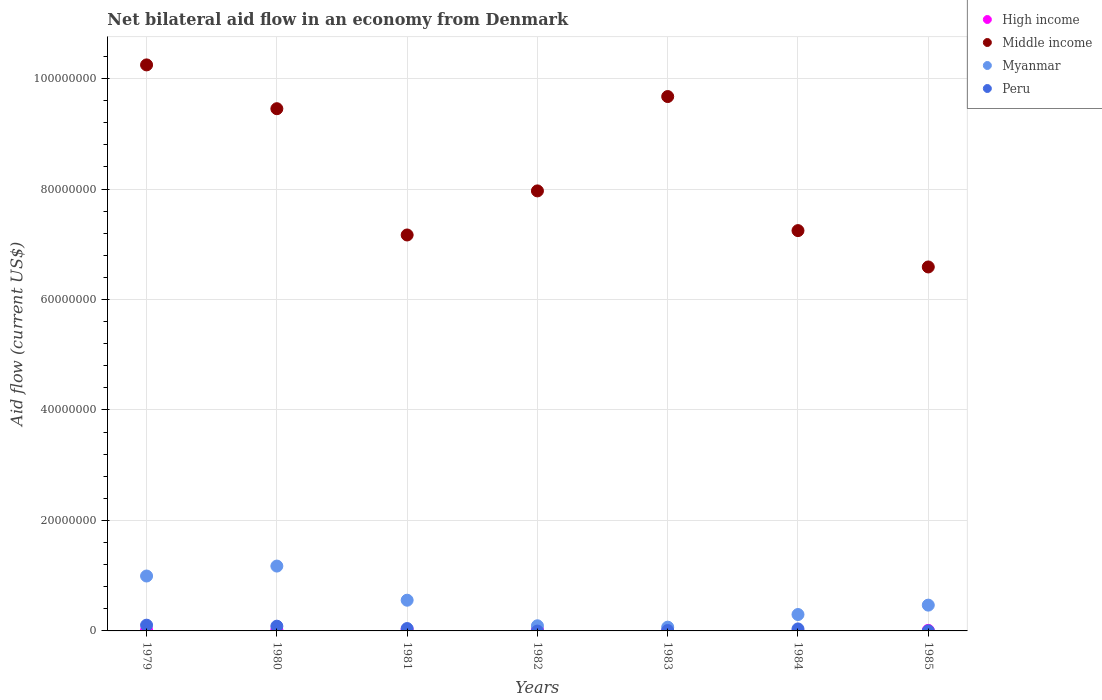How many different coloured dotlines are there?
Ensure brevity in your answer.  4. Is the number of dotlines equal to the number of legend labels?
Your response must be concise. No. What is the net bilateral aid flow in Myanmar in 1983?
Ensure brevity in your answer.  6.80e+05. Across all years, what is the maximum net bilateral aid flow in Peru?
Offer a terse response. 1.04e+06. In which year was the net bilateral aid flow in Peru maximum?
Your response must be concise. 1979. What is the total net bilateral aid flow in High income in the graph?
Your answer should be very brief. 9.50e+05. What is the difference between the net bilateral aid flow in Peru in 1979 and that in 1984?
Offer a very short reply. 6.80e+05. What is the difference between the net bilateral aid flow in Peru in 1984 and the net bilateral aid flow in Myanmar in 1981?
Offer a very short reply. -5.20e+06. What is the average net bilateral aid flow in High income per year?
Provide a short and direct response. 1.36e+05. In the year 1980, what is the difference between the net bilateral aid flow in Myanmar and net bilateral aid flow in High income?
Your answer should be very brief. 1.16e+07. In how many years, is the net bilateral aid flow in Peru greater than 88000000 US$?
Provide a short and direct response. 0. What is the ratio of the net bilateral aid flow in Middle income in 1979 to that in 1984?
Provide a succinct answer. 1.41. Is the net bilateral aid flow in High income in 1980 less than that in 1982?
Ensure brevity in your answer.  Yes. What is the difference between the highest and the second highest net bilateral aid flow in Middle income?
Offer a very short reply. 5.73e+06. What is the difference between the highest and the lowest net bilateral aid flow in High income?
Your answer should be very brief. 2.40e+05. Is the sum of the net bilateral aid flow in High income in 1982 and 1983 greater than the maximum net bilateral aid flow in Middle income across all years?
Provide a short and direct response. No. Is it the case that in every year, the sum of the net bilateral aid flow in Middle income and net bilateral aid flow in Myanmar  is greater than the sum of net bilateral aid flow in High income and net bilateral aid flow in Peru?
Ensure brevity in your answer.  Yes. Does the net bilateral aid flow in High income monotonically increase over the years?
Keep it short and to the point. No. Is the net bilateral aid flow in Peru strictly greater than the net bilateral aid flow in Myanmar over the years?
Provide a short and direct response. No. How many dotlines are there?
Provide a short and direct response. 4. How many years are there in the graph?
Provide a short and direct response. 7. What is the difference between two consecutive major ticks on the Y-axis?
Ensure brevity in your answer.  2.00e+07. Does the graph contain any zero values?
Your response must be concise. Yes. How are the legend labels stacked?
Make the answer very short. Vertical. What is the title of the graph?
Offer a terse response. Net bilateral aid flow in an economy from Denmark. Does "Malta" appear as one of the legend labels in the graph?
Ensure brevity in your answer.  No. What is the label or title of the X-axis?
Provide a succinct answer. Years. What is the label or title of the Y-axis?
Keep it short and to the point. Aid flow (current US$). What is the Aid flow (current US$) of Middle income in 1979?
Your answer should be compact. 1.02e+08. What is the Aid flow (current US$) of Myanmar in 1979?
Your answer should be compact. 9.94e+06. What is the Aid flow (current US$) in Peru in 1979?
Ensure brevity in your answer.  1.04e+06. What is the Aid flow (current US$) of Middle income in 1980?
Your response must be concise. 9.45e+07. What is the Aid flow (current US$) in Myanmar in 1980?
Offer a very short reply. 1.17e+07. What is the Aid flow (current US$) of Peru in 1980?
Your answer should be very brief. 8.60e+05. What is the Aid flow (current US$) of High income in 1981?
Provide a succinct answer. 2.40e+05. What is the Aid flow (current US$) of Middle income in 1981?
Ensure brevity in your answer.  7.17e+07. What is the Aid flow (current US$) of Myanmar in 1981?
Ensure brevity in your answer.  5.56e+06. What is the Aid flow (current US$) in Middle income in 1982?
Offer a terse response. 7.97e+07. What is the Aid flow (current US$) in Myanmar in 1982?
Your answer should be compact. 9.30e+05. What is the Aid flow (current US$) of Peru in 1982?
Provide a succinct answer. 0. What is the Aid flow (current US$) in Middle income in 1983?
Offer a terse response. 9.67e+07. What is the Aid flow (current US$) in Myanmar in 1983?
Offer a terse response. 6.80e+05. What is the Aid flow (current US$) in Middle income in 1984?
Keep it short and to the point. 7.25e+07. What is the Aid flow (current US$) in Myanmar in 1984?
Your response must be concise. 2.97e+06. What is the Aid flow (current US$) of Peru in 1984?
Give a very brief answer. 3.60e+05. What is the Aid flow (current US$) of Middle income in 1985?
Give a very brief answer. 6.59e+07. What is the Aid flow (current US$) in Myanmar in 1985?
Offer a very short reply. 4.67e+06. What is the Aid flow (current US$) in Peru in 1985?
Offer a terse response. 10000. Across all years, what is the maximum Aid flow (current US$) of Middle income?
Provide a short and direct response. 1.02e+08. Across all years, what is the maximum Aid flow (current US$) in Myanmar?
Ensure brevity in your answer.  1.17e+07. Across all years, what is the maximum Aid flow (current US$) in Peru?
Your answer should be compact. 1.04e+06. Across all years, what is the minimum Aid flow (current US$) in High income?
Offer a very short reply. 0. Across all years, what is the minimum Aid flow (current US$) of Middle income?
Keep it short and to the point. 6.59e+07. Across all years, what is the minimum Aid flow (current US$) of Myanmar?
Offer a terse response. 6.80e+05. Across all years, what is the minimum Aid flow (current US$) in Peru?
Make the answer very short. 0. What is the total Aid flow (current US$) of High income in the graph?
Keep it short and to the point. 9.50e+05. What is the total Aid flow (current US$) in Middle income in the graph?
Give a very brief answer. 5.83e+08. What is the total Aid flow (current US$) in Myanmar in the graph?
Your answer should be very brief. 3.65e+07. What is the total Aid flow (current US$) in Peru in the graph?
Give a very brief answer. 2.77e+06. What is the difference between the Aid flow (current US$) in High income in 1979 and that in 1980?
Keep it short and to the point. -4.00e+04. What is the difference between the Aid flow (current US$) in Middle income in 1979 and that in 1980?
Make the answer very short. 7.93e+06. What is the difference between the Aid flow (current US$) in Myanmar in 1979 and that in 1980?
Provide a succinct answer. -1.80e+06. What is the difference between the Aid flow (current US$) in High income in 1979 and that in 1981?
Your answer should be compact. -1.00e+05. What is the difference between the Aid flow (current US$) of Middle income in 1979 and that in 1981?
Your answer should be very brief. 3.08e+07. What is the difference between the Aid flow (current US$) of Myanmar in 1979 and that in 1981?
Your response must be concise. 4.38e+06. What is the difference between the Aid flow (current US$) of High income in 1979 and that in 1982?
Your answer should be compact. -1.00e+05. What is the difference between the Aid flow (current US$) in Middle income in 1979 and that in 1982?
Keep it short and to the point. 2.28e+07. What is the difference between the Aid flow (current US$) of Myanmar in 1979 and that in 1982?
Your answer should be very brief. 9.01e+06. What is the difference between the Aid flow (current US$) of Middle income in 1979 and that in 1983?
Your answer should be compact. 5.73e+06. What is the difference between the Aid flow (current US$) in Myanmar in 1979 and that in 1983?
Offer a very short reply. 9.26e+06. What is the difference between the Aid flow (current US$) of Peru in 1979 and that in 1983?
Keep it short and to the point. 9.70e+05. What is the difference between the Aid flow (current US$) of Middle income in 1979 and that in 1984?
Give a very brief answer. 3.00e+07. What is the difference between the Aid flow (current US$) of Myanmar in 1979 and that in 1984?
Make the answer very short. 6.97e+06. What is the difference between the Aid flow (current US$) of Peru in 1979 and that in 1984?
Make the answer very short. 6.80e+05. What is the difference between the Aid flow (current US$) of Middle income in 1979 and that in 1985?
Provide a short and direct response. 3.66e+07. What is the difference between the Aid flow (current US$) of Myanmar in 1979 and that in 1985?
Your response must be concise. 5.27e+06. What is the difference between the Aid flow (current US$) in Peru in 1979 and that in 1985?
Ensure brevity in your answer.  1.03e+06. What is the difference between the Aid flow (current US$) of High income in 1980 and that in 1981?
Provide a short and direct response. -6.00e+04. What is the difference between the Aid flow (current US$) of Middle income in 1980 and that in 1981?
Offer a terse response. 2.29e+07. What is the difference between the Aid flow (current US$) in Myanmar in 1980 and that in 1981?
Give a very brief answer. 6.18e+06. What is the difference between the Aid flow (current US$) in Peru in 1980 and that in 1981?
Your answer should be compact. 4.30e+05. What is the difference between the Aid flow (current US$) in High income in 1980 and that in 1982?
Ensure brevity in your answer.  -6.00e+04. What is the difference between the Aid flow (current US$) in Middle income in 1980 and that in 1982?
Your answer should be very brief. 1.49e+07. What is the difference between the Aid flow (current US$) in Myanmar in 1980 and that in 1982?
Offer a terse response. 1.08e+07. What is the difference between the Aid flow (current US$) of Middle income in 1980 and that in 1983?
Provide a short and direct response. -2.20e+06. What is the difference between the Aid flow (current US$) of Myanmar in 1980 and that in 1983?
Your answer should be compact. 1.11e+07. What is the difference between the Aid flow (current US$) of Peru in 1980 and that in 1983?
Provide a succinct answer. 7.90e+05. What is the difference between the Aid flow (current US$) of Middle income in 1980 and that in 1984?
Give a very brief answer. 2.21e+07. What is the difference between the Aid flow (current US$) of Myanmar in 1980 and that in 1984?
Offer a terse response. 8.77e+06. What is the difference between the Aid flow (current US$) of Middle income in 1980 and that in 1985?
Make the answer very short. 2.86e+07. What is the difference between the Aid flow (current US$) in Myanmar in 1980 and that in 1985?
Offer a terse response. 7.07e+06. What is the difference between the Aid flow (current US$) in Peru in 1980 and that in 1985?
Your answer should be compact. 8.50e+05. What is the difference between the Aid flow (current US$) of High income in 1981 and that in 1982?
Make the answer very short. 0. What is the difference between the Aid flow (current US$) in Middle income in 1981 and that in 1982?
Offer a very short reply. -7.98e+06. What is the difference between the Aid flow (current US$) in Myanmar in 1981 and that in 1982?
Your response must be concise. 4.63e+06. What is the difference between the Aid flow (current US$) of Middle income in 1981 and that in 1983?
Your answer should be very brief. -2.51e+07. What is the difference between the Aid flow (current US$) of Myanmar in 1981 and that in 1983?
Your response must be concise. 4.88e+06. What is the difference between the Aid flow (current US$) of Middle income in 1981 and that in 1984?
Ensure brevity in your answer.  -7.90e+05. What is the difference between the Aid flow (current US$) in Myanmar in 1981 and that in 1984?
Offer a terse response. 2.59e+06. What is the difference between the Aid flow (current US$) of Peru in 1981 and that in 1984?
Provide a short and direct response. 7.00e+04. What is the difference between the Aid flow (current US$) in Middle income in 1981 and that in 1985?
Give a very brief answer. 5.79e+06. What is the difference between the Aid flow (current US$) in Myanmar in 1981 and that in 1985?
Provide a short and direct response. 8.90e+05. What is the difference between the Aid flow (current US$) in Peru in 1981 and that in 1985?
Make the answer very short. 4.20e+05. What is the difference between the Aid flow (current US$) of High income in 1982 and that in 1983?
Provide a short and direct response. 1.90e+05. What is the difference between the Aid flow (current US$) in Middle income in 1982 and that in 1983?
Provide a short and direct response. -1.71e+07. What is the difference between the Aid flow (current US$) of Middle income in 1982 and that in 1984?
Ensure brevity in your answer.  7.19e+06. What is the difference between the Aid flow (current US$) in Myanmar in 1982 and that in 1984?
Your response must be concise. -2.04e+06. What is the difference between the Aid flow (current US$) of High income in 1982 and that in 1985?
Your answer should be very brief. 1.40e+05. What is the difference between the Aid flow (current US$) in Middle income in 1982 and that in 1985?
Make the answer very short. 1.38e+07. What is the difference between the Aid flow (current US$) in Myanmar in 1982 and that in 1985?
Your answer should be very brief. -3.74e+06. What is the difference between the Aid flow (current US$) of Middle income in 1983 and that in 1984?
Ensure brevity in your answer.  2.43e+07. What is the difference between the Aid flow (current US$) in Myanmar in 1983 and that in 1984?
Ensure brevity in your answer.  -2.29e+06. What is the difference between the Aid flow (current US$) in Peru in 1983 and that in 1984?
Give a very brief answer. -2.90e+05. What is the difference between the Aid flow (current US$) of High income in 1983 and that in 1985?
Provide a succinct answer. -5.00e+04. What is the difference between the Aid flow (current US$) of Middle income in 1983 and that in 1985?
Make the answer very short. 3.08e+07. What is the difference between the Aid flow (current US$) of Myanmar in 1983 and that in 1985?
Ensure brevity in your answer.  -3.99e+06. What is the difference between the Aid flow (current US$) of Middle income in 1984 and that in 1985?
Give a very brief answer. 6.58e+06. What is the difference between the Aid flow (current US$) of Myanmar in 1984 and that in 1985?
Keep it short and to the point. -1.70e+06. What is the difference between the Aid flow (current US$) in Peru in 1984 and that in 1985?
Your answer should be compact. 3.50e+05. What is the difference between the Aid flow (current US$) of High income in 1979 and the Aid flow (current US$) of Middle income in 1980?
Ensure brevity in your answer.  -9.44e+07. What is the difference between the Aid flow (current US$) of High income in 1979 and the Aid flow (current US$) of Myanmar in 1980?
Offer a very short reply. -1.16e+07. What is the difference between the Aid flow (current US$) of High income in 1979 and the Aid flow (current US$) of Peru in 1980?
Make the answer very short. -7.20e+05. What is the difference between the Aid flow (current US$) in Middle income in 1979 and the Aid flow (current US$) in Myanmar in 1980?
Give a very brief answer. 9.07e+07. What is the difference between the Aid flow (current US$) in Middle income in 1979 and the Aid flow (current US$) in Peru in 1980?
Make the answer very short. 1.02e+08. What is the difference between the Aid flow (current US$) of Myanmar in 1979 and the Aid flow (current US$) of Peru in 1980?
Your response must be concise. 9.08e+06. What is the difference between the Aid flow (current US$) in High income in 1979 and the Aid flow (current US$) in Middle income in 1981?
Your answer should be compact. -7.15e+07. What is the difference between the Aid flow (current US$) in High income in 1979 and the Aid flow (current US$) in Myanmar in 1981?
Keep it short and to the point. -5.42e+06. What is the difference between the Aid flow (current US$) of High income in 1979 and the Aid flow (current US$) of Peru in 1981?
Your answer should be compact. -2.90e+05. What is the difference between the Aid flow (current US$) in Middle income in 1979 and the Aid flow (current US$) in Myanmar in 1981?
Your response must be concise. 9.69e+07. What is the difference between the Aid flow (current US$) of Middle income in 1979 and the Aid flow (current US$) of Peru in 1981?
Your answer should be compact. 1.02e+08. What is the difference between the Aid flow (current US$) of Myanmar in 1979 and the Aid flow (current US$) of Peru in 1981?
Provide a succinct answer. 9.51e+06. What is the difference between the Aid flow (current US$) of High income in 1979 and the Aid flow (current US$) of Middle income in 1982?
Keep it short and to the point. -7.95e+07. What is the difference between the Aid flow (current US$) of High income in 1979 and the Aid flow (current US$) of Myanmar in 1982?
Your answer should be very brief. -7.90e+05. What is the difference between the Aid flow (current US$) in Middle income in 1979 and the Aid flow (current US$) in Myanmar in 1982?
Give a very brief answer. 1.02e+08. What is the difference between the Aid flow (current US$) of High income in 1979 and the Aid flow (current US$) of Middle income in 1983?
Provide a short and direct response. -9.66e+07. What is the difference between the Aid flow (current US$) in High income in 1979 and the Aid flow (current US$) in Myanmar in 1983?
Provide a short and direct response. -5.40e+05. What is the difference between the Aid flow (current US$) in High income in 1979 and the Aid flow (current US$) in Peru in 1983?
Provide a succinct answer. 7.00e+04. What is the difference between the Aid flow (current US$) in Middle income in 1979 and the Aid flow (current US$) in Myanmar in 1983?
Keep it short and to the point. 1.02e+08. What is the difference between the Aid flow (current US$) of Middle income in 1979 and the Aid flow (current US$) of Peru in 1983?
Your answer should be very brief. 1.02e+08. What is the difference between the Aid flow (current US$) in Myanmar in 1979 and the Aid flow (current US$) in Peru in 1983?
Offer a very short reply. 9.87e+06. What is the difference between the Aid flow (current US$) of High income in 1979 and the Aid flow (current US$) of Middle income in 1984?
Your response must be concise. -7.23e+07. What is the difference between the Aid flow (current US$) of High income in 1979 and the Aid flow (current US$) of Myanmar in 1984?
Your answer should be very brief. -2.83e+06. What is the difference between the Aid flow (current US$) of Middle income in 1979 and the Aid flow (current US$) of Myanmar in 1984?
Your response must be concise. 9.95e+07. What is the difference between the Aid flow (current US$) of Middle income in 1979 and the Aid flow (current US$) of Peru in 1984?
Your answer should be compact. 1.02e+08. What is the difference between the Aid flow (current US$) of Myanmar in 1979 and the Aid flow (current US$) of Peru in 1984?
Offer a very short reply. 9.58e+06. What is the difference between the Aid flow (current US$) of High income in 1979 and the Aid flow (current US$) of Middle income in 1985?
Keep it short and to the point. -6.58e+07. What is the difference between the Aid flow (current US$) of High income in 1979 and the Aid flow (current US$) of Myanmar in 1985?
Give a very brief answer. -4.53e+06. What is the difference between the Aid flow (current US$) in Middle income in 1979 and the Aid flow (current US$) in Myanmar in 1985?
Make the answer very short. 9.78e+07. What is the difference between the Aid flow (current US$) in Middle income in 1979 and the Aid flow (current US$) in Peru in 1985?
Offer a terse response. 1.02e+08. What is the difference between the Aid flow (current US$) in Myanmar in 1979 and the Aid flow (current US$) in Peru in 1985?
Your answer should be very brief. 9.93e+06. What is the difference between the Aid flow (current US$) in High income in 1980 and the Aid flow (current US$) in Middle income in 1981?
Make the answer very short. -7.15e+07. What is the difference between the Aid flow (current US$) of High income in 1980 and the Aid flow (current US$) of Myanmar in 1981?
Your response must be concise. -5.38e+06. What is the difference between the Aid flow (current US$) in High income in 1980 and the Aid flow (current US$) in Peru in 1981?
Provide a short and direct response. -2.50e+05. What is the difference between the Aid flow (current US$) in Middle income in 1980 and the Aid flow (current US$) in Myanmar in 1981?
Provide a succinct answer. 8.90e+07. What is the difference between the Aid flow (current US$) of Middle income in 1980 and the Aid flow (current US$) of Peru in 1981?
Your answer should be very brief. 9.41e+07. What is the difference between the Aid flow (current US$) of Myanmar in 1980 and the Aid flow (current US$) of Peru in 1981?
Offer a very short reply. 1.13e+07. What is the difference between the Aid flow (current US$) of High income in 1980 and the Aid flow (current US$) of Middle income in 1982?
Give a very brief answer. -7.95e+07. What is the difference between the Aid flow (current US$) of High income in 1980 and the Aid flow (current US$) of Myanmar in 1982?
Keep it short and to the point. -7.50e+05. What is the difference between the Aid flow (current US$) of Middle income in 1980 and the Aid flow (current US$) of Myanmar in 1982?
Provide a short and direct response. 9.36e+07. What is the difference between the Aid flow (current US$) in High income in 1980 and the Aid flow (current US$) in Middle income in 1983?
Your answer should be very brief. -9.66e+07. What is the difference between the Aid flow (current US$) in High income in 1980 and the Aid flow (current US$) in Myanmar in 1983?
Your response must be concise. -5.00e+05. What is the difference between the Aid flow (current US$) in Middle income in 1980 and the Aid flow (current US$) in Myanmar in 1983?
Keep it short and to the point. 9.39e+07. What is the difference between the Aid flow (current US$) in Middle income in 1980 and the Aid flow (current US$) in Peru in 1983?
Provide a succinct answer. 9.45e+07. What is the difference between the Aid flow (current US$) of Myanmar in 1980 and the Aid flow (current US$) of Peru in 1983?
Provide a succinct answer. 1.17e+07. What is the difference between the Aid flow (current US$) of High income in 1980 and the Aid flow (current US$) of Middle income in 1984?
Give a very brief answer. -7.23e+07. What is the difference between the Aid flow (current US$) of High income in 1980 and the Aid flow (current US$) of Myanmar in 1984?
Provide a succinct answer. -2.79e+06. What is the difference between the Aid flow (current US$) in Middle income in 1980 and the Aid flow (current US$) in Myanmar in 1984?
Your answer should be very brief. 9.16e+07. What is the difference between the Aid flow (current US$) in Middle income in 1980 and the Aid flow (current US$) in Peru in 1984?
Ensure brevity in your answer.  9.42e+07. What is the difference between the Aid flow (current US$) of Myanmar in 1980 and the Aid flow (current US$) of Peru in 1984?
Your answer should be compact. 1.14e+07. What is the difference between the Aid flow (current US$) in High income in 1980 and the Aid flow (current US$) in Middle income in 1985?
Your response must be concise. -6.57e+07. What is the difference between the Aid flow (current US$) in High income in 1980 and the Aid flow (current US$) in Myanmar in 1985?
Your response must be concise. -4.49e+06. What is the difference between the Aid flow (current US$) in High income in 1980 and the Aid flow (current US$) in Peru in 1985?
Give a very brief answer. 1.70e+05. What is the difference between the Aid flow (current US$) in Middle income in 1980 and the Aid flow (current US$) in Myanmar in 1985?
Your answer should be very brief. 8.99e+07. What is the difference between the Aid flow (current US$) of Middle income in 1980 and the Aid flow (current US$) of Peru in 1985?
Offer a very short reply. 9.45e+07. What is the difference between the Aid flow (current US$) of Myanmar in 1980 and the Aid flow (current US$) of Peru in 1985?
Keep it short and to the point. 1.17e+07. What is the difference between the Aid flow (current US$) in High income in 1981 and the Aid flow (current US$) in Middle income in 1982?
Offer a very short reply. -7.94e+07. What is the difference between the Aid flow (current US$) of High income in 1981 and the Aid flow (current US$) of Myanmar in 1982?
Your answer should be compact. -6.90e+05. What is the difference between the Aid flow (current US$) of Middle income in 1981 and the Aid flow (current US$) of Myanmar in 1982?
Your answer should be very brief. 7.08e+07. What is the difference between the Aid flow (current US$) in High income in 1981 and the Aid flow (current US$) in Middle income in 1983?
Your answer should be compact. -9.65e+07. What is the difference between the Aid flow (current US$) in High income in 1981 and the Aid flow (current US$) in Myanmar in 1983?
Your answer should be compact. -4.40e+05. What is the difference between the Aid flow (current US$) of High income in 1981 and the Aid flow (current US$) of Peru in 1983?
Ensure brevity in your answer.  1.70e+05. What is the difference between the Aid flow (current US$) of Middle income in 1981 and the Aid flow (current US$) of Myanmar in 1983?
Offer a very short reply. 7.10e+07. What is the difference between the Aid flow (current US$) in Middle income in 1981 and the Aid flow (current US$) in Peru in 1983?
Your answer should be compact. 7.16e+07. What is the difference between the Aid flow (current US$) of Myanmar in 1981 and the Aid flow (current US$) of Peru in 1983?
Your response must be concise. 5.49e+06. What is the difference between the Aid flow (current US$) of High income in 1981 and the Aid flow (current US$) of Middle income in 1984?
Keep it short and to the point. -7.22e+07. What is the difference between the Aid flow (current US$) in High income in 1981 and the Aid flow (current US$) in Myanmar in 1984?
Keep it short and to the point. -2.73e+06. What is the difference between the Aid flow (current US$) in Middle income in 1981 and the Aid flow (current US$) in Myanmar in 1984?
Your answer should be very brief. 6.87e+07. What is the difference between the Aid flow (current US$) in Middle income in 1981 and the Aid flow (current US$) in Peru in 1984?
Provide a short and direct response. 7.13e+07. What is the difference between the Aid flow (current US$) in Myanmar in 1981 and the Aid flow (current US$) in Peru in 1984?
Keep it short and to the point. 5.20e+06. What is the difference between the Aid flow (current US$) of High income in 1981 and the Aid flow (current US$) of Middle income in 1985?
Keep it short and to the point. -6.56e+07. What is the difference between the Aid flow (current US$) in High income in 1981 and the Aid flow (current US$) in Myanmar in 1985?
Make the answer very short. -4.43e+06. What is the difference between the Aid flow (current US$) in Middle income in 1981 and the Aid flow (current US$) in Myanmar in 1985?
Keep it short and to the point. 6.70e+07. What is the difference between the Aid flow (current US$) of Middle income in 1981 and the Aid flow (current US$) of Peru in 1985?
Your answer should be very brief. 7.17e+07. What is the difference between the Aid flow (current US$) of Myanmar in 1981 and the Aid flow (current US$) of Peru in 1985?
Offer a very short reply. 5.55e+06. What is the difference between the Aid flow (current US$) in High income in 1982 and the Aid flow (current US$) in Middle income in 1983?
Offer a terse response. -9.65e+07. What is the difference between the Aid flow (current US$) in High income in 1982 and the Aid flow (current US$) in Myanmar in 1983?
Your response must be concise. -4.40e+05. What is the difference between the Aid flow (current US$) in Middle income in 1982 and the Aid flow (current US$) in Myanmar in 1983?
Provide a succinct answer. 7.90e+07. What is the difference between the Aid flow (current US$) in Middle income in 1982 and the Aid flow (current US$) in Peru in 1983?
Keep it short and to the point. 7.96e+07. What is the difference between the Aid flow (current US$) in Myanmar in 1982 and the Aid flow (current US$) in Peru in 1983?
Provide a succinct answer. 8.60e+05. What is the difference between the Aid flow (current US$) of High income in 1982 and the Aid flow (current US$) of Middle income in 1984?
Offer a very short reply. -7.22e+07. What is the difference between the Aid flow (current US$) of High income in 1982 and the Aid flow (current US$) of Myanmar in 1984?
Offer a terse response. -2.73e+06. What is the difference between the Aid flow (current US$) in High income in 1982 and the Aid flow (current US$) in Peru in 1984?
Offer a very short reply. -1.20e+05. What is the difference between the Aid flow (current US$) of Middle income in 1982 and the Aid flow (current US$) of Myanmar in 1984?
Offer a very short reply. 7.67e+07. What is the difference between the Aid flow (current US$) in Middle income in 1982 and the Aid flow (current US$) in Peru in 1984?
Give a very brief answer. 7.93e+07. What is the difference between the Aid flow (current US$) in Myanmar in 1982 and the Aid flow (current US$) in Peru in 1984?
Make the answer very short. 5.70e+05. What is the difference between the Aid flow (current US$) in High income in 1982 and the Aid flow (current US$) in Middle income in 1985?
Ensure brevity in your answer.  -6.56e+07. What is the difference between the Aid flow (current US$) in High income in 1982 and the Aid flow (current US$) in Myanmar in 1985?
Your answer should be very brief. -4.43e+06. What is the difference between the Aid flow (current US$) in High income in 1982 and the Aid flow (current US$) in Peru in 1985?
Provide a succinct answer. 2.30e+05. What is the difference between the Aid flow (current US$) in Middle income in 1982 and the Aid flow (current US$) in Myanmar in 1985?
Your response must be concise. 7.50e+07. What is the difference between the Aid flow (current US$) in Middle income in 1982 and the Aid flow (current US$) in Peru in 1985?
Offer a terse response. 7.96e+07. What is the difference between the Aid flow (current US$) in Myanmar in 1982 and the Aid flow (current US$) in Peru in 1985?
Keep it short and to the point. 9.20e+05. What is the difference between the Aid flow (current US$) in High income in 1983 and the Aid flow (current US$) in Middle income in 1984?
Provide a succinct answer. -7.24e+07. What is the difference between the Aid flow (current US$) of High income in 1983 and the Aid flow (current US$) of Myanmar in 1984?
Your response must be concise. -2.92e+06. What is the difference between the Aid flow (current US$) of High income in 1983 and the Aid flow (current US$) of Peru in 1984?
Ensure brevity in your answer.  -3.10e+05. What is the difference between the Aid flow (current US$) in Middle income in 1983 and the Aid flow (current US$) in Myanmar in 1984?
Keep it short and to the point. 9.38e+07. What is the difference between the Aid flow (current US$) of Middle income in 1983 and the Aid flow (current US$) of Peru in 1984?
Make the answer very short. 9.64e+07. What is the difference between the Aid flow (current US$) of Myanmar in 1983 and the Aid flow (current US$) of Peru in 1984?
Keep it short and to the point. 3.20e+05. What is the difference between the Aid flow (current US$) in High income in 1983 and the Aid flow (current US$) in Middle income in 1985?
Your answer should be very brief. -6.58e+07. What is the difference between the Aid flow (current US$) of High income in 1983 and the Aid flow (current US$) of Myanmar in 1985?
Ensure brevity in your answer.  -4.62e+06. What is the difference between the Aid flow (current US$) of High income in 1983 and the Aid flow (current US$) of Peru in 1985?
Your answer should be very brief. 4.00e+04. What is the difference between the Aid flow (current US$) in Middle income in 1983 and the Aid flow (current US$) in Myanmar in 1985?
Give a very brief answer. 9.21e+07. What is the difference between the Aid flow (current US$) of Middle income in 1983 and the Aid flow (current US$) of Peru in 1985?
Make the answer very short. 9.67e+07. What is the difference between the Aid flow (current US$) of Myanmar in 1983 and the Aid flow (current US$) of Peru in 1985?
Offer a terse response. 6.70e+05. What is the difference between the Aid flow (current US$) of Middle income in 1984 and the Aid flow (current US$) of Myanmar in 1985?
Keep it short and to the point. 6.78e+07. What is the difference between the Aid flow (current US$) of Middle income in 1984 and the Aid flow (current US$) of Peru in 1985?
Provide a succinct answer. 7.25e+07. What is the difference between the Aid flow (current US$) of Myanmar in 1984 and the Aid flow (current US$) of Peru in 1985?
Your response must be concise. 2.96e+06. What is the average Aid flow (current US$) of High income per year?
Make the answer very short. 1.36e+05. What is the average Aid flow (current US$) of Middle income per year?
Offer a very short reply. 8.34e+07. What is the average Aid flow (current US$) of Myanmar per year?
Offer a very short reply. 5.21e+06. What is the average Aid flow (current US$) in Peru per year?
Offer a terse response. 3.96e+05. In the year 1979, what is the difference between the Aid flow (current US$) in High income and Aid flow (current US$) in Middle income?
Offer a very short reply. -1.02e+08. In the year 1979, what is the difference between the Aid flow (current US$) of High income and Aid flow (current US$) of Myanmar?
Offer a very short reply. -9.80e+06. In the year 1979, what is the difference between the Aid flow (current US$) of High income and Aid flow (current US$) of Peru?
Your response must be concise. -9.00e+05. In the year 1979, what is the difference between the Aid flow (current US$) of Middle income and Aid flow (current US$) of Myanmar?
Ensure brevity in your answer.  9.25e+07. In the year 1979, what is the difference between the Aid flow (current US$) in Middle income and Aid flow (current US$) in Peru?
Your response must be concise. 1.01e+08. In the year 1979, what is the difference between the Aid flow (current US$) of Myanmar and Aid flow (current US$) of Peru?
Offer a very short reply. 8.90e+06. In the year 1980, what is the difference between the Aid flow (current US$) in High income and Aid flow (current US$) in Middle income?
Ensure brevity in your answer.  -9.44e+07. In the year 1980, what is the difference between the Aid flow (current US$) of High income and Aid flow (current US$) of Myanmar?
Your response must be concise. -1.16e+07. In the year 1980, what is the difference between the Aid flow (current US$) in High income and Aid flow (current US$) in Peru?
Provide a succinct answer. -6.80e+05. In the year 1980, what is the difference between the Aid flow (current US$) in Middle income and Aid flow (current US$) in Myanmar?
Provide a short and direct response. 8.28e+07. In the year 1980, what is the difference between the Aid flow (current US$) of Middle income and Aid flow (current US$) of Peru?
Your answer should be very brief. 9.37e+07. In the year 1980, what is the difference between the Aid flow (current US$) of Myanmar and Aid flow (current US$) of Peru?
Make the answer very short. 1.09e+07. In the year 1981, what is the difference between the Aid flow (current US$) of High income and Aid flow (current US$) of Middle income?
Your answer should be very brief. -7.14e+07. In the year 1981, what is the difference between the Aid flow (current US$) in High income and Aid flow (current US$) in Myanmar?
Give a very brief answer. -5.32e+06. In the year 1981, what is the difference between the Aid flow (current US$) of High income and Aid flow (current US$) of Peru?
Keep it short and to the point. -1.90e+05. In the year 1981, what is the difference between the Aid flow (current US$) in Middle income and Aid flow (current US$) in Myanmar?
Provide a succinct answer. 6.61e+07. In the year 1981, what is the difference between the Aid flow (current US$) of Middle income and Aid flow (current US$) of Peru?
Provide a succinct answer. 7.12e+07. In the year 1981, what is the difference between the Aid flow (current US$) in Myanmar and Aid flow (current US$) in Peru?
Your answer should be very brief. 5.13e+06. In the year 1982, what is the difference between the Aid flow (current US$) of High income and Aid flow (current US$) of Middle income?
Keep it short and to the point. -7.94e+07. In the year 1982, what is the difference between the Aid flow (current US$) of High income and Aid flow (current US$) of Myanmar?
Give a very brief answer. -6.90e+05. In the year 1982, what is the difference between the Aid flow (current US$) of Middle income and Aid flow (current US$) of Myanmar?
Ensure brevity in your answer.  7.87e+07. In the year 1983, what is the difference between the Aid flow (current US$) in High income and Aid flow (current US$) in Middle income?
Provide a succinct answer. -9.67e+07. In the year 1983, what is the difference between the Aid flow (current US$) in High income and Aid flow (current US$) in Myanmar?
Give a very brief answer. -6.30e+05. In the year 1983, what is the difference between the Aid flow (current US$) of High income and Aid flow (current US$) of Peru?
Offer a terse response. -2.00e+04. In the year 1983, what is the difference between the Aid flow (current US$) in Middle income and Aid flow (current US$) in Myanmar?
Your answer should be very brief. 9.61e+07. In the year 1983, what is the difference between the Aid flow (current US$) of Middle income and Aid flow (current US$) of Peru?
Your response must be concise. 9.67e+07. In the year 1984, what is the difference between the Aid flow (current US$) in Middle income and Aid flow (current US$) in Myanmar?
Provide a succinct answer. 6.95e+07. In the year 1984, what is the difference between the Aid flow (current US$) in Middle income and Aid flow (current US$) in Peru?
Make the answer very short. 7.21e+07. In the year 1984, what is the difference between the Aid flow (current US$) in Myanmar and Aid flow (current US$) in Peru?
Ensure brevity in your answer.  2.61e+06. In the year 1985, what is the difference between the Aid flow (current US$) in High income and Aid flow (current US$) in Middle income?
Keep it short and to the point. -6.58e+07. In the year 1985, what is the difference between the Aid flow (current US$) in High income and Aid flow (current US$) in Myanmar?
Offer a very short reply. -4.57e+06. In the year 1985, what is the difference between the Aid flow (current US$) in High income and Aid flow (current US$) in Peru?
Make the answer very short. 9.00e+04. In the year 1985, what is the difference between the Aid flow (current US$) of Middle income and Aid flow (current US$) of Myanmar?
Offer a very short reply. 6.12e+07. In the year 1985, what is the difference between the Aid flow (current US$) in Middle income and Aid flow (current US$) in Peru?
Make the answer very short. 6.59e+07. In the year 1985, what is the difference between the Aid flow (current US$) in Myanmar and Aid flow (current US$) in Peru?
Give a very brief answer. 4.66e+06. What is the ratio of the Aid flow (current US$) of High income in 1979 to that in 1980?
Make the answer very short. 0.78. What is the ratio of the Aid flow (current US$) in Middle income in 1979 to that in 1980?
Ensure brevity in your answer.  1.08. What is the ratio of the Aid flow (current US$) of Myanmar in 1979 to that in 1980?
Offer a terse response. 0.85. What is the ratio of the Aid flow (current US$) of Peru in 1979 to that in 1980?
Provide a short and direct response. 1.21. What is the ratio of the Aid flow (current US$) of High income in 1979 to that in 1981?
Offer a very short reply. 0.58. What is the ratio of the Aid flow (current US$) in Middle income in 1979 to that in 1981?
Your answer should be very brief. 1.43. What is the ratio of the Aid flow (current US$) in Myanmar in 1979 to that in 1981?
Offer a terse response. 1.79. What is the ratio of the Aid flow (current US$) of Peru in 1979 to that in 1981?
Offer a very short reply. 2.42. What is the ratio of the Aid flow (current US$) of High income in 1979 to that in 1982?
Offer a very short reply. 0.58. What is the ratio of the Aid flow (current US$) of Middle income in 1979 to that in 1982?
Offer a very short reply. 1.29. What is the ratio of the Aid flow (current US$) of Myanmar in 1979 to that in 1982?
Ensure brevity in your answer.  10.69. What is the ratio of the Aid flow (current US$) in Middle income in 1979 to that in 1983?
Ensure brevity in your answer.  1.06. What is the ratio of the Aid flow (current US$) in Myanmar in 1979 to that in 1983?
Offer a terse response. 14.62. What is the ratio of the Aid flow (current US$) in Peru in 1979 to that in 1983?
Ensure brevity in your answer.  14.86. What is the ratio of the Aid flow (current US$) of Middle income in 1979 to that in 1984?
Your response must be concise. 1.41. What is the ratio of the Aid flow (current US$) of Myanmar in 1979 to that in 1984?
Your response must be concise. 3.35. What is the ratio of the Aid flow (current US$) in Peru in 1979 to that in 1984?
Provide a succinct answer. 2.89. What is the ratio of the Aid flow (current US$) of Middle income in 1979 to that in 1985?
Ensure brevity in your answer.  1.56. What is the ratio of the Aid flow (current US$) in Myanmar in 1979 to that in 1985?
Keep it short and to the point. 2.13. What is the ratio of the Aid flow (current US$) in Peru in 1979 to that in 1985?
Provide a short and direct response. 104. What is the ratio of the Aid flow (current US$) of Middle income in 1980 to that in 1981?
Provide a succinct answer. 1.32. What is the ratio of the Aid flow (current US$) of Myanmar in 1980 to that in 1981?
Give a very brief answer. 2.11. What is the ratio of the Aid flow (current US$) in Peru in 1980 to that in 1981?
Your answer should be compact. 2. What is the ratio of the Aid flow (current US$) in Middle income in 1980 to that in 1982?
Keep it short and to the point. 1.19. What is the ratio of the Aid flow (current US$) of Myanmar in 1980 to that in 1982?
Your answer should be compact. 12.62. What is the ratio of the Aid flow (current US$) in High income in 1980 to that in 1983?
Offer a terse response. 3.6. What is the ratio of the Aid flow (current US$) in Middle income in 1980 to that in 1983?
Provide a succinct answer. 0.98. What is the ratio of the Aid flow (current US$) of Myanmar in 1980 to that in 1983?
Make the answer very short. 17.26. What is the ratio of the Aid flow (current US$) of Peru in 1980 to that in 1983?
Give a very brief answer. 12.29. What is the ratio of the Aid flow (current US$) of Middle income in 1980 to that in 1984?
Keep it short and to the point. 1.3. What is the ratio of the Aid flow (current US$) of Myanmar in 1980 to that in 1984?
Your answer should be compact. 3.95. What is the ratio of the Aid flow (current US$) in Peru in 1980 to that in 1984?
Your answer should be compact. 2.39. What is the ratio of the Aid flow (current US$) of Middle income in 1980 to that in 1985?
Your answer should be very brief. 1.43. What is the ratio of the Aid flow (current US$) in Myanmar in 1980 to that in 1985?
Offer a terse response. 2.51. What is the ratio of the Aid flow (current US$) in Peru in 1980 to that in 1985?
Your response must be concise. 86. What is the ratio of the Aid flow (current US$) in Middle income in 1981 to that in 1982?
Your answer should be compact. 0.9. What is the ratio of the Aid flow (current US$) of Myanmar in 1981 to that in 1982?
Keep it short and to the point. 5.98. What is the ratio of the Aid flow (current US$) of Middle income in 1981 to that in 1983?
Offer a terse response. 0.74. What is the ratio of the Aid flow (current US$) in Myanmar in 1981 to that in 1983?
Ensure brevity in your answer.  8.18. What is the ratio of the Aid flow (current US$) of Peru in 1981 to that in 1983?
Keep it short and to the point. 6.14. What is the ratio of the Aid flow (current US$) of Myanmar in 1981 to that in 1984?
Give a very brief answer. 1.87. What is the ratio of the Aid flow (current US$) in Peru in 1981 to that in 1984?
Provide a short and direct response. 1.19. What is the ratio of the Aid flow (current US$) of High income in 1981 to that in 1985?
Keep it short and to the point. 2.4. What is the ratio of the Aid flow (current US$) of Middle income in 1981 to that in 1985?
Make the answer very short. 1.09. What is the ratio of the Aid flow (current US$) in Myanmar in 1981 to that in 1985?
Ensure brevity in your answer.  1.19. What is the ratio of the Aid flow (current US$) in Peru in 1981 to that in 1985?
Your response must be concise. 43. What is the ratio of the Aid flow (current US$) in Middle income in 1982 to that in 1983?
Provide a succinct answer. 0.82. What is the ratio of the Aid flow (current US$) of Myanmar in 1982 to that in 1983?
Your response must be concise. 1.37. What is the ratio of the Aid flow (current US$) of Middle income in 1982 to that in 1984?
Your response must be concise. 1.1. What is the ratio of the Aid flow (current US$) of Myanmar in 1982 to that in 1984?
Give a very brief answer. 0.31. What is the ratio of the Aid flow (current US$) of High income in 1982 to that in 1985?
Your answer should be very brief. 2.4. What is the ratio of the Aid flow (current US$) in Middle income in 1982 to that in 1985?
Your answer should be compact. 1.21. What is the ratio of the Aid flow (current US$) in Myanmar in 1982 to that in 1985?
Your answer should be very brief. 0.2. What is the ratio of the Aid flow (current US$) of Middle income in 1983 to that in 1984?
Provide a succinct answer. 1.33. What is the ratio of the Aid flow (current US$) in Myanmar in 1983 to that in 1984?
Your response must be concise. 0.23. What is the ratio of the Aid flow (current US$) of Peru in 1983 to that in 1984?
Keep it short and to the point. 0.19. What is the ratio of the Aid flow (current US$) in High income in 1983 to that in 1985?
Give a very brief answer. 0.5. What is the ratio of the Aid flow (current US$) of Middle income in 1983 to that in 1985?
Your answer should be very brief. 1.47. What is the ratio of the Aid flow (current US$) of Myanmar in 1983 to that in 1985?
Your answer should be compact. 0.15. What is the ratio of the Aid flow (current US$) in Middle income in 1984 to that in 1985?
Keep it short and to the point. 1.1. What is the ratio of the Aid flow (current US$) of Myanmar in 1984 to that in 1985?
Provide a short and direct response. 0.64. What is the difference between the highest and the second highest Aid flow (current US$) in Middle income?
Provide a short and direct response. 5.73e+06. What is the difference between the highest and the second highest Aid flow (current US$) of Myanmar?
Your response must be concise. 1.80e+06. What is the difference between the highest and the second highest Aid flow (current US$) of Peru?
Your response must be concise. 1.80e+05. What is the difference between the highest and the lowest Aid flow (current US$) in High income?
Ensure brevity in your answer.  2.40e+05. What is the difference between the highest and the lowest Aid flow (current US$) in Middle income?
Ensure brevity in your answer.  3.66e+07. What is the difference between the highest and the lowest Aid flow (current US$) in Myanmar?
Give a very brief answer. 1.11e+07. What is the difference between the highest and the lowest Aid flow (current US$) of Peru?
Your answer should be very brief. 1.04e+06. 